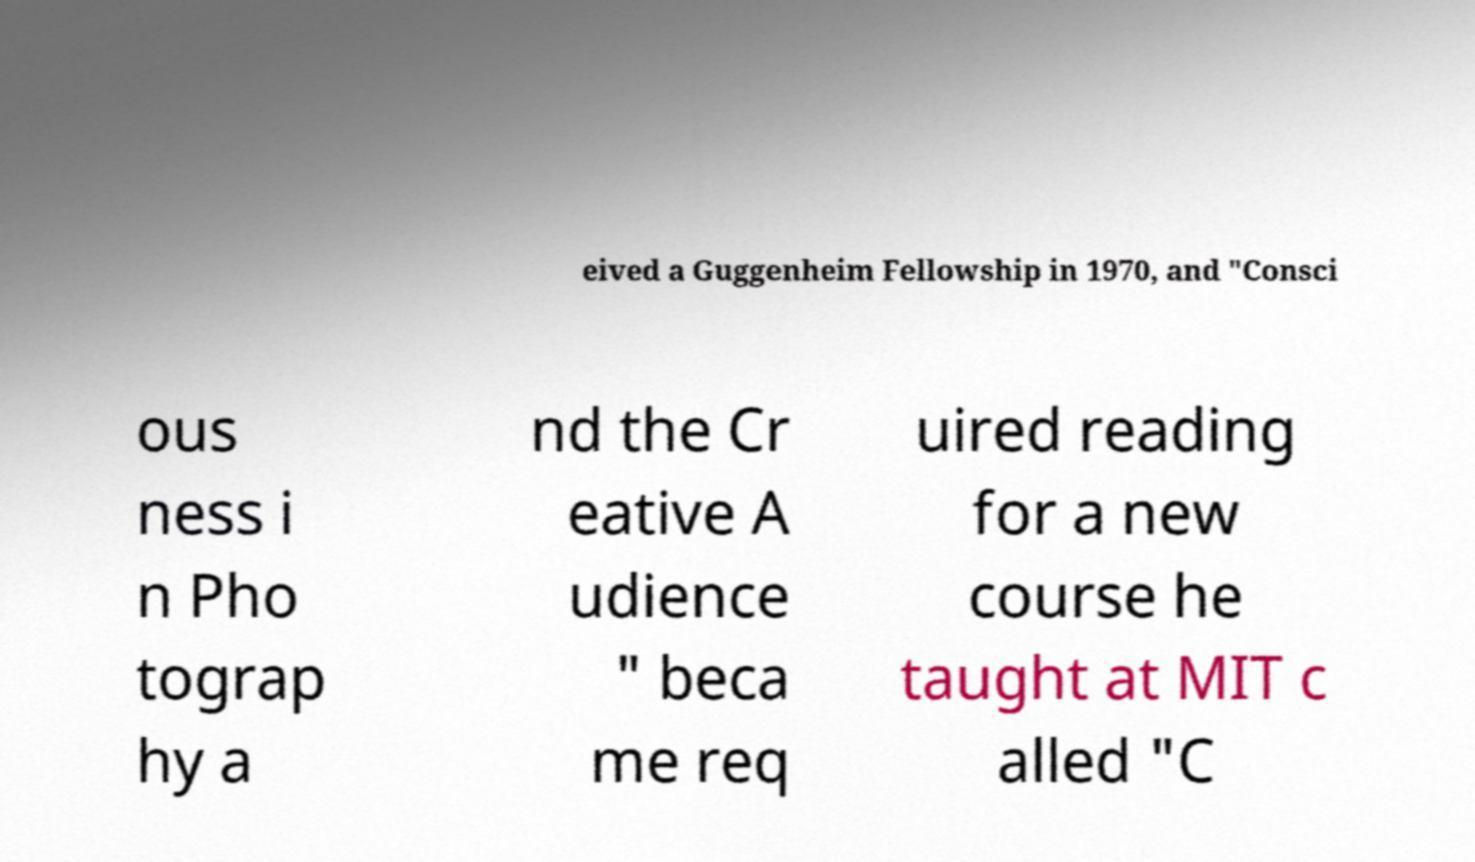I need the written content from this picture converted into text. Can you do that? eived a Guggenheim Fellowship in 1970, and "Consci ous ness i n Pho tograp hy a nd the Cr eative A udience " beca me req uired reading for a new course he taught at MIT c alled "C 